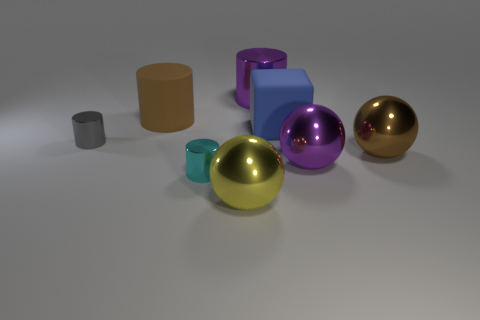Subtract 1 cylinders. How many cylinders are left? 3 Add 1 big yellow metallic cylinders. How many objects exist? 9 Subtract all cubes. How many objects are left? 7 Add 4 small metallic cylinders. How many small metallic cylinders are left? 6 Add 5 gray shiny cylinders. How many gray shiny cylinders exist? 6 Subtract 1 yellow balls. How many objects are left? 7 Subtract all large yellow rubber objects. Subtract all big rubber objects. How many objects are left? 6 